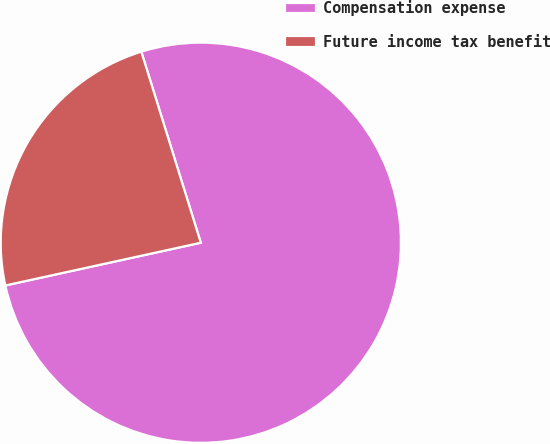<chart> <loc_0><loc_0><loc_500><loc_500><pie_chart><fcel>Compensation expense<fcel>Future income tax benefit<nl><fcel>76.38%<fcel>23.62%<nl></chart> 